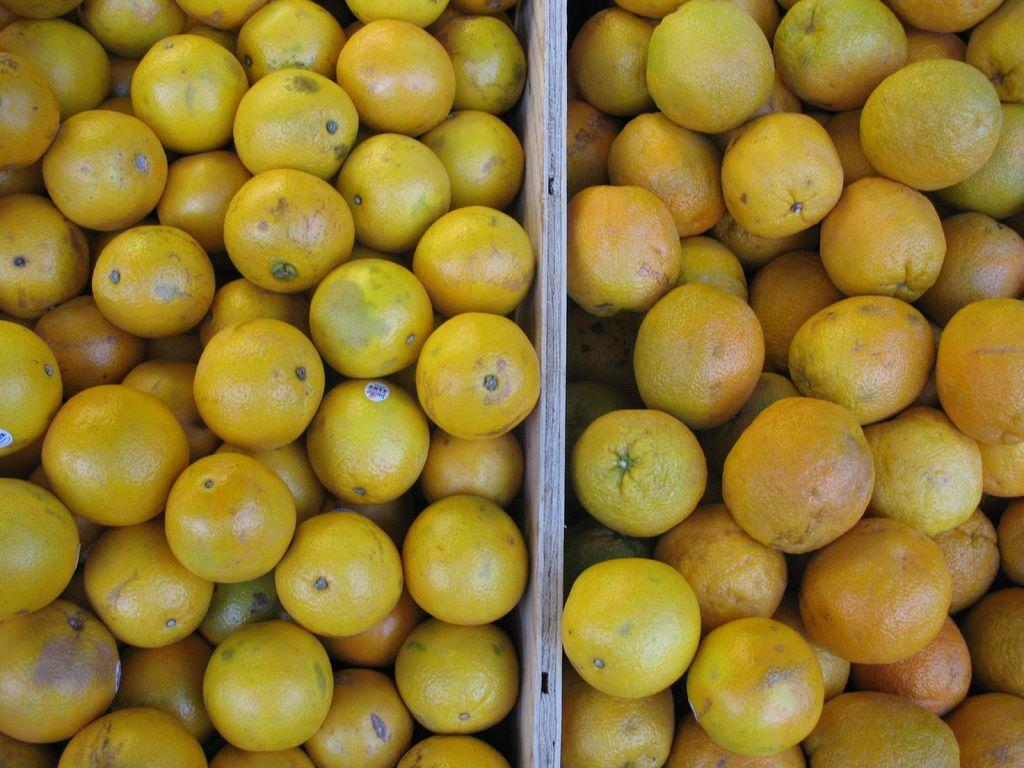What type of fruit is visible in the image? There are oranges in the image. What separates the image into two distinct sections? There is a partition at the center of the image. How many trees are visible in the image? There are no trees visible in the image. What type of shelter is set up in the image? There is no shelter, such as a tent, present in the image. 